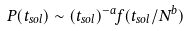Convert formula to latex. <formula><loc_0><loc_0><loc_500><loc_500>P ( t _ { s o l } ) \sim ( t _ { s o l } ) ^ { - a } f ( t _ { s o l } / N ^ { b } )</formula> 